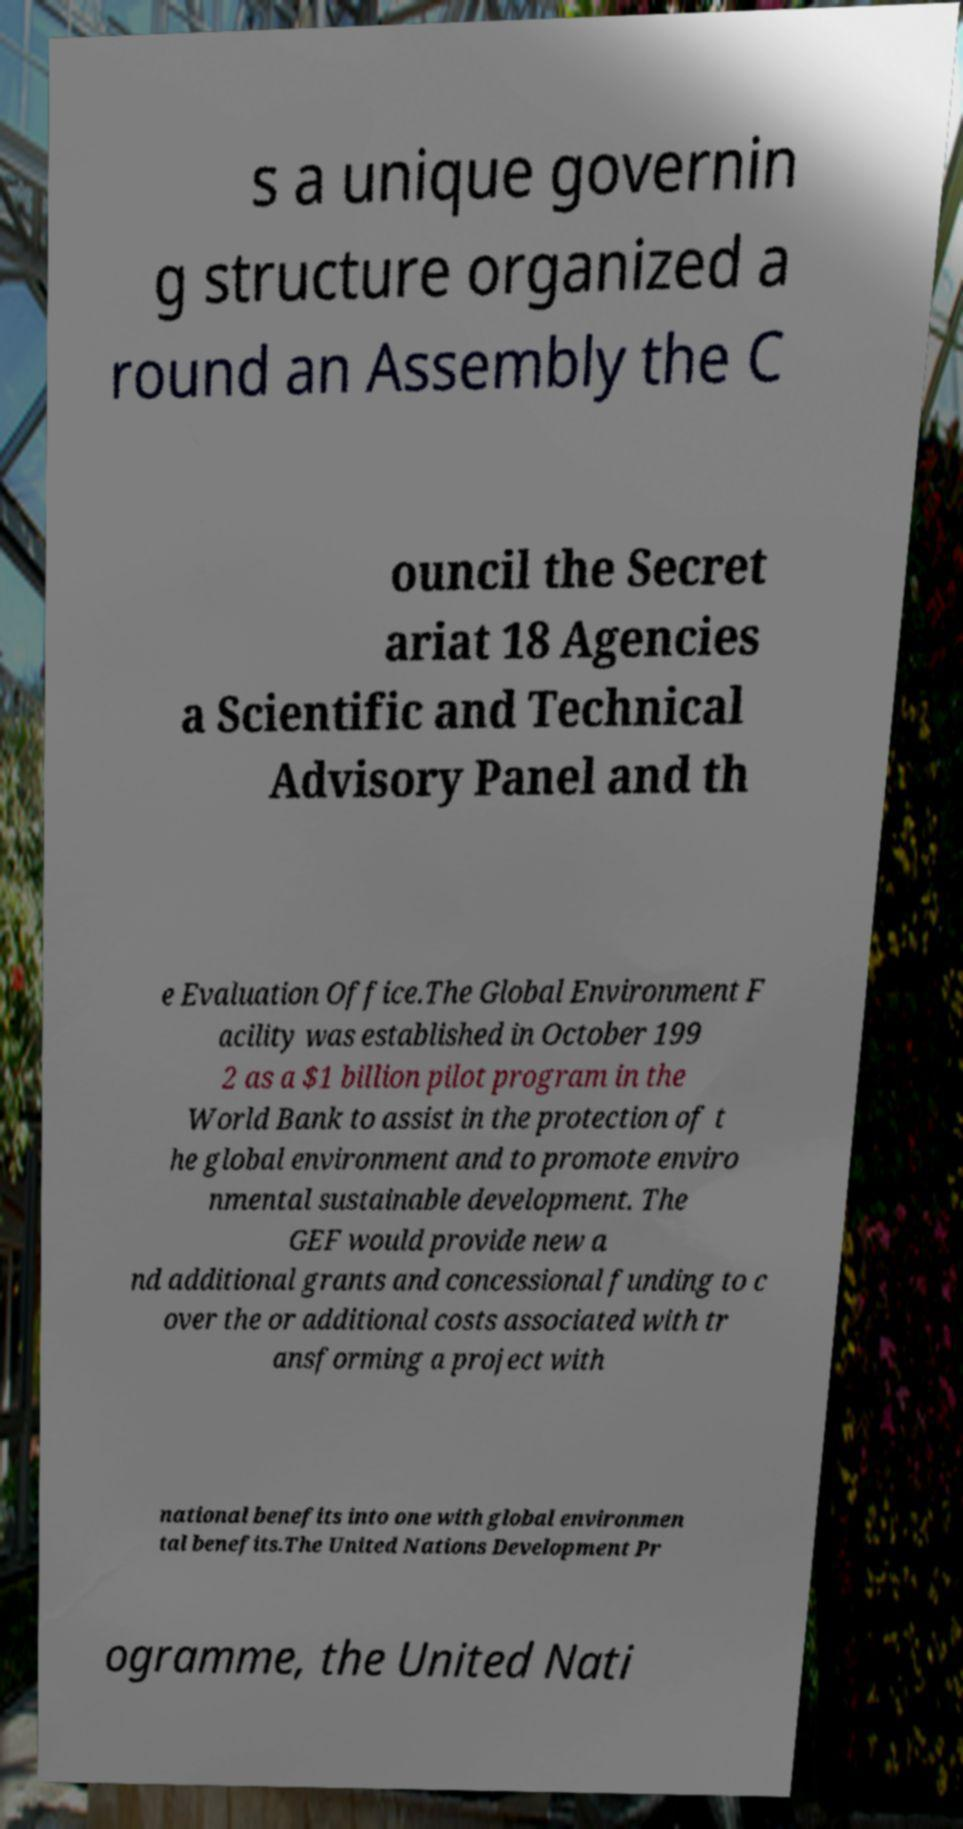For documentation purposes, I need the text within this image transcribed. Could you provide that? s a unique governin g structure organized a round an Assembly the C ouncil the Secret ariat 18 Agencies a Scientific and Technical Advisory Panel and th e Evaluation Office.The Global Environment F acility was established in October 199 2 as a $1 billion pilot program in the World Bank to assist in the protection of t he global environment and to promote enviro nmental sustainable development. The GEF would provide new a nd additional grants and concessional funding to c over the or additional costs associated with tr ansforming a project with national benefits into one with global environmen tal benefits.The United Nations Development Pr ogramme, the United Nati 